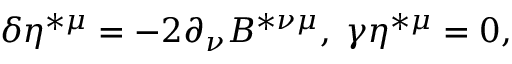Convert formula to latex. <formula><loc_0><loc_0><loc_500><loc_500>\delta \eta ^ { * \mu } = - 2 \partial _ { \nu } B ^ { * \nu \mu } , \, \gamma \eta ^ { * \mu } = 0 ,</formula> 